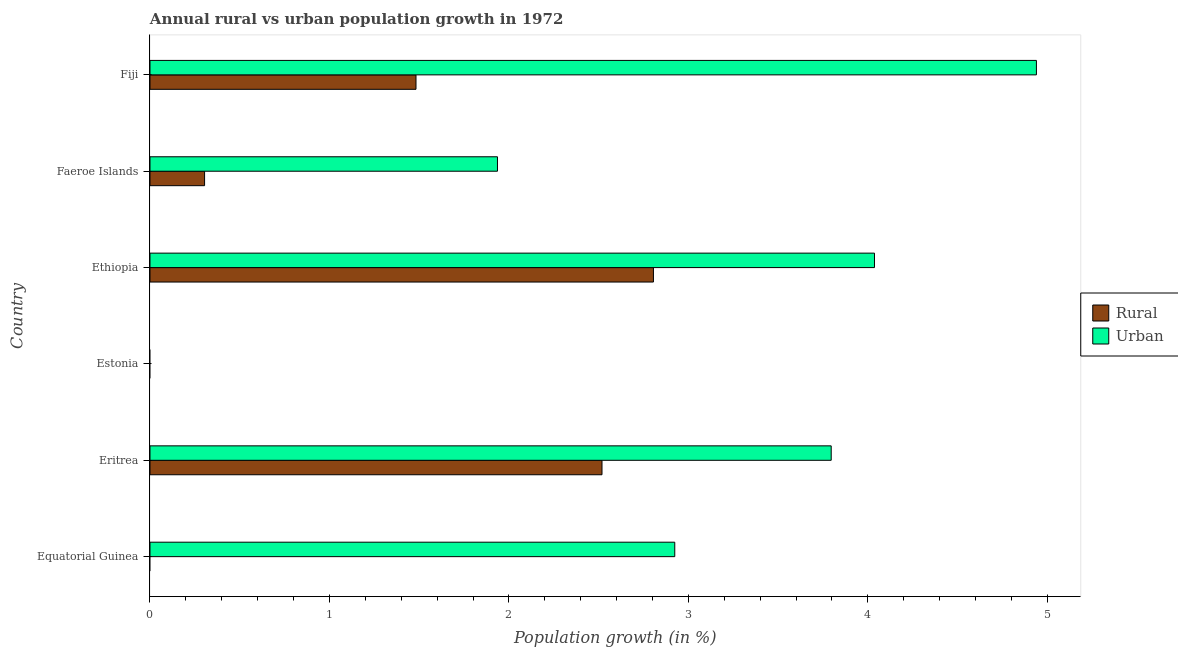How many different coloured bars are there?
Keep it short and to the point. 2. Are the number of bars per tick equal to the number of legend labels?
Ensure brevity in your answer.  No. How many bars are there on the 3rd tick from the top?
Keep it short and to the point. 2. What is the label of the 5th group of bars from the top?
Offer a terse response. Eritrea. In how many cases, is the number of bars for a given country not equal to the number of legend labels?
Offer a very short reply. 2. Across all countries, what is the maximum urban population growth?
Your answer should be very brief. 4.94. In which country was the rural population growth maximum?
Offer a terse response. Ethiopia. What is the total urban population growth in the graph?
Your answer should be compact. 17.63. What is the difference between the rural population growth in Ethiopia and that in Faeroe Islands?
Provide a succinct answer. 2.5. What is the difference between the urban population growth in Eritrea and the rural population growth in Equatorial Guinea?
Give a very brief answer. 3.8. What is the average urban population growth per country?
Your answer should be very brief. 2.94. What is the difference between the rural population growth and urban population growth in Fiji?
Offer a terse response. -3.46. In how many countries, is the rural population growth greater than 4.8 %?
Give a very brief answer. 0. What is the ratio of the rural population growth in Ethiopia to that in Faeroe Islands?
Provide a succinct answer. 9.22. Is the difference between the rural population growth in Eritrea and Fiji greater than the difference between the urban population growth in Eritrea and Fiji?
Give a very brief answer. Yes. What is the difference between the highest and the second highest rural population growth?
Offer a terse response. 0.29. What is the difference between the highest and the lowest urban population growth?
Your response must be concise. 4.94. In how many countries, is the rural population growth greater than the average rural population growth taken over all countries?
Offer a terse response. 3. How many countries are there in the graph?
Your answer should be very brief. 6. Does the graph contain any zero values?
Your answer should be very brief. Yes. What is the title of the graph?
Your answer should be compact. Annual rural vs urban population growth in 1972. Does "Private consumption" appear as one of the legend labels in the graph?
Provide a short and direct response. No. What is the label or title of the X-axis?
Your response must be concise. Population growth (in %). What is the Population growth (in %) in Urban  in Equatorial Guinea?
Provide a succinct answer. 2.92. What is the Population growth (in %) in Rural in Eritrea?
Give a very brief answer. 2.52. What is the Population growth (in %) of Urban  in Eritrea?
Make the answer very short. 3.8. What is the Population growth (in %) of Urban  in Estonia?
Your response must be concise. 0. What is the Population growth (in %) in Rural in Ethiopia?
Offer a very short reply. 2.81. What is the Population growth (in %) in Urban  in Ethiopia?
Offer a terse response. 4.04. What is the Population growth (in %) in Rural in Faeroe Islands?
Make the answer very short. 0.3. What is the Population growth (in %) in Urban  in Faeroe Islands?
Your answer should be compact. 1.94. What is the Population growth (in %) in Rural in Fiji?
Your answer should be very brief. 1.48. What is the Population growth (in %) in Urban  in Fiji?
Your answer should be very brief. 4.94. Across all countries, what is the maximum Population growth (in %) of Rural?
Your answer should be very brief. 2.81. Across all countries, what is the maximum Population growth (in %) of Urban ?
Give a very brief answer. 4.94. What is the total Population growth (in %) in Rural in the graph?
Offer a terse response. 7.11. What is the total Population growth (in %) in Urban  in the graph?
Your answer should be very brief. 17.63. What is the difference between the Population growth (in %) of Urban  in Equatorial Guinea and that in Eritrea?
Provide a short and direct response. -0.87. What is the difference between the Population growth (in %) in Urban  in Equatorial Guinea and that in Ethiopia?
Your response must be concise. -1.11. What is the difference between the Population growth (in %) of Urban  in Equatorial Guinea and that in Faeroe Islands?
Give a very brief answer. 0.99. What is the difference between the Population growth (in %) in Urban  in Equatorial Guinea and that in Fiji?
Offer a terse response. -2.02. What is the difference between the Population growth (in %) in Rural in Eritrea and that in Ethiopia?
Your answer should be compact. -0.29. What is the difference between the Population growth (in %) of Urban  in Eritrea and that in Ethiopia?
Offer a very short reply. -0.24. What is the difference between the Population growth (in %) of Rural in Eritrea and that in Faeroe Islands?
Your response must be concise. 2.21. What is the difference between the Population growth (in %) in Urban  in Eritrea and that in Faeroe Islands?
Keep it short and to the point. 1.86. What is the difference between the Population growth (in %) in Rural in Eritrea and that in Fiji?
Ensure brevity in your answer.  1.04. What is the difference between the Population growth (in %) of Urban  in Eritrea and that in Fiji?
Your response must be concise. -1.14. What is the difference between the Population growth (in %) in Rural in Ethiopia and that in Faeroe Islands?
Ensure brevity in your answer.  2.5. What is the difference between the Population growth (in %) in Urban  in Ethiopia and that in Faeroe Islands?
Ensure brevity in your answer.  2.1. What is the difference between the Population growth (in %) in Rural in Ethiopia and that in Fiji?
Your answer should be very brief. 1.32. What is the difference between the Population growth (in %) of Urban  in Ethiopia and that in Fiji?
Give a very brief answer. -0.9. What is the difference between the Population growth (in %) of Rural in Faeroe Islands and that in Fiji?
Give a very brief answer. -1.18. What is the difference between the Population growth (in %) in Urban  in Faeroe Islands and that in Fiji?
Your answer should be very brief. -3. What is the difference between the Population growth (in %) of Rural in Eritrea and the Population growth (in %) of Urban  in Ethiopia?
Ensure brevity in your answer.  -1.52. What is the difference between the Population growth (in %) in Rural in Eritrea and the Population growth (in %) in Urban  in Faeroe Islands?
Your response must be concise. 0.58. What is the difference between the Population growth (in %) of Rural in Eritrea and the Population growth (in %) of Urban  in Fiji?
Give a very brief answer. -2.42. What is the difference between the Population growth (in %) in Rural in Ethiopia and the Population growth (in %) in Urban  in Faeroe Islands?
Keep it short and to the point. 0.87. What is the difference between the Population growth (in %) of Rural in Ethiopia and the Population growth (in %) of Urban  in Fiji?
Ensure brevity in your answer.  -2.13. What is the difference between the Population growth (in %) of Rural in Faeroe Islands and the Population growth (in %) of Urban  in Fiji?
Make the answer very short. -4.63. What is the average Population growth (in %) of Rural per country?
Provide a succinct answer. 1.19. What is the average Population growth (in %) in Urban  per country?
Provide a short and direct response. 2.94. What is the difference between the Population growth (in %) of Rural and Population growth (in %) of Urban  in Eritrea?
Ensure brevity in your answer.  -1.28. What is the difference between the Population growth (in %) in Rural and Population growth (in %) in Urban  in Ethiopia?
Your answer should be very brief. -1.23. What is the difference between the Population growth (in %) in Rural and Population growth (in %) in Urban  in Faeroe Islands?
Provide a short and direct response. -1.63. What is the difference between the Population growth (in %) of Rural and Population growth (in %) of Urban  in Fiji?
Keep it short and to the point. -3.46. What is the ratio of the Population growth (in %) of Urban  in Equatorial Guinea to that in Eritrea?
Provide a short and direct response. 0.77. What is the ratio of the Population growth (in %) in Urban  in Equatorial Guinea to that in Ethiopia?
Make the answer very short. 0.72. What is the ratio of the Population growth (in %) in Urban  in Equatorial Guinea to that in Faeroe Islands?
Offer a very short reply. 1.51. What is the ratio of the Population growth (in %) of Urban  in Equatorial Guinea to that in Fiji?
Your answer should be compact. 0.59. What is the ratio of the Population growth (in %) of Rural in Eritrea to that in Ethiopia?
Your answer should be compact. 0.9. What is the ratio of the Population growth (in %) of Urban  in Eritrea to that in Ethiopia?
Make the answer very short. 0.94. What is the ratio of the Population growth (in %) of Rural in Eritrea to that in Faeroe Islands?
Your answer should be compact. 8.28. What is the ratio of the Population growth (in %) of Urban  in Eritrea to that in Faeroe Islands?
Provide a succinct answer. 1.96. What is the ratio of the Population growth (in %) of Rural in Eritrea to that in Fiji?
Make the answer very short. 1.7. What is the ratio of the Population growth (in %) in Urban  in Eritrea to that in Fiji?
Give a very brief answer. 0.77. What is the ratio of the Population growth (in %) in Rural in Ethiopia to that in Faeroe Islands?
Keep it short and to the point. 9.22. What is the ratio of the Population growth (in %) of Urban  in Ethiopia to that in Faeroe Islands?
Your answer should be compact. 2.08. What is the ratio of the Population growth (in %) of Rural in Ethiopia to that in Fiji?
Make the answer very short. 1.89. What is the ratio of the Population growth (in %) of Urban  in Ethiopia to that in Fiji?
Keep it short and to the point. 0.82. What is the ratio of the Population growth (in %) of Rural in Faeroe Islands to that in Fiji?
Your answer should be very brief. 0.21. What is the ratio of the Population growth (in %) in Urban  in Faeroe Islands to that in Fiji?
Keep it short and to the point. 0.39. What is the difference between the highest and the second highest Population growth (in %) in Rural?
Make the answer very short. 0.29. What is the difference between the highest and the second highest Population growth (in %) of Urban ?
Your answer should be compact. 0.9. What is the difference between the highest and the lowest Population growth (in %) in Rural?
Make the answer very short. 2.81. What is the difference between the highest and the lowest Population growth (in %) of Urban ?
Your response must be concise. 4.94. 